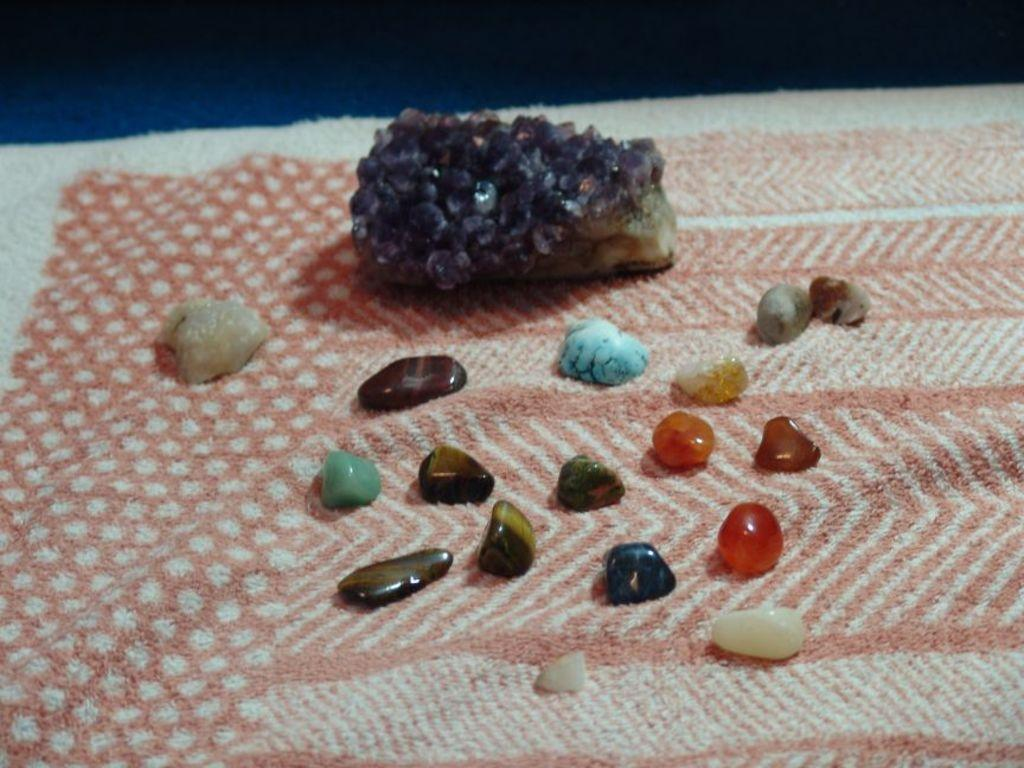What type of items can be seen in the image? There are clothes in the image. What is on the clothes? There are color stones on the clothes. Where is the library located in the image? There is no library present in the image. What type of breakfast is being served on the clothes? There is no breakfast present in the image; it features clothes with color stones. 